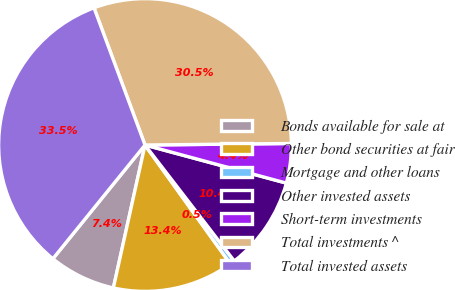Convert chart. <chart><loc_0><loc_0><loc_500><loc_500><pie_chart><fcel>Bonds available for sale at<fcel>Other bond securities at fair<fcel>Mortgage and other loans<fcel>Other invested assets<fcel>Short-term investments<fcel>Total investments ^<fcel>Total invested assets<nl><fcel>7.37%<fcel>13.38%<fcel>0.53%<fcel>10.37%<fcel>4.36%<fcel>30.5%<fcel>33.5%<nl></chart> 